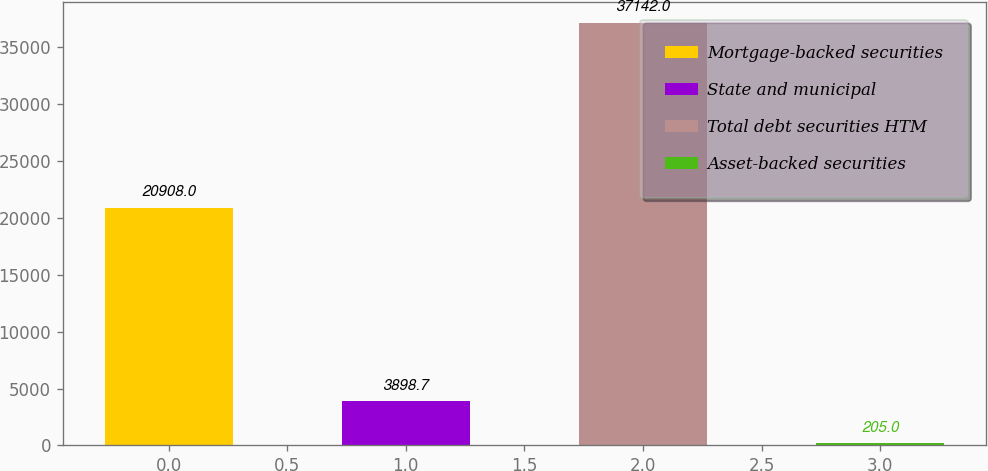Convert chart. <chart><loc_0><loc_0><loc_500><loc_500><bar_chart><fcel>Mortgage-backed securities<fcel>State and municipal<fcel>Total debt securities HTM<fcel>Asset-backed securities<nl><fcel>20908<fcel>3898.7<fcel>37142<fcel>205<nl></chart> 